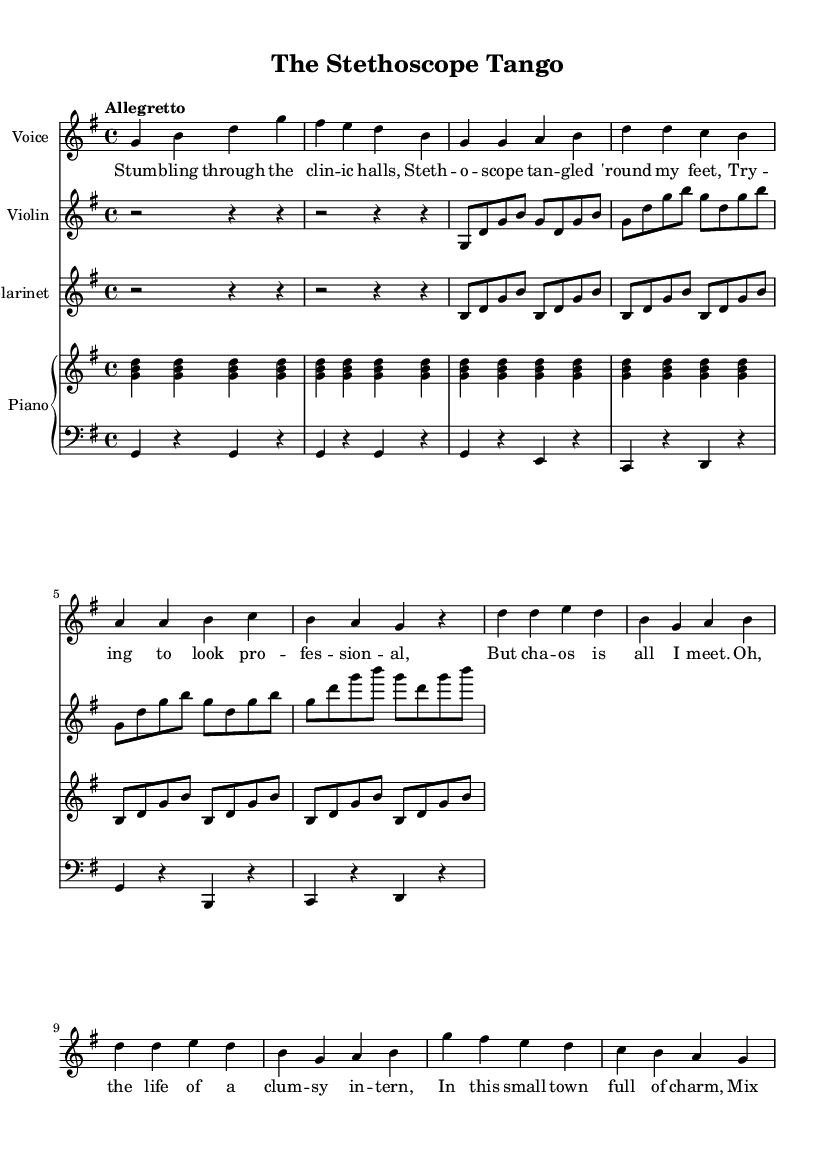What is the key signature of this music? The key signature is G major, which has one sharp (F#). We can find this by looking at the beginning of the staff where the sharps or flats are indicated.
Answer: G major What is the time signature of this music? The time signature is 4/4. This is identified by the fraction symbol displayed at the beginning of the score indicating four beats per measure, with the quarter note being one beat.
Answer: 4/4 What is the tempo indication for this piece? The tempo indication is "Allegretto." This term is typically indicated in the tempo marking at the beginning of the score and suggests a moderately fast pace.
Answer: Allegretto What is the instrumentation used in this opera? The instrumentation includes Voice, Violin, Clarinet, and Piano. The names of the instruments are listed at the start of each staff in the score.
Answer: Voice, Violin, Clarinet, Piano How many measures are there in the introduction? There are 2 measures in the introduction. By counting the groups of four beats in the introduction section, we determine the total.
Answer: 2 measures In the chorus, what device is used to create a sense of humor in the lyrics? The device used is "comic relief." The playful mishaps described in the lyrics contribute to the humorous tone typical in comic opera. This can be inferred from the light-hearted context and the intern's clumsiness mentioned in the lyrics.
Answer: Comic relief What is the primary theme of this comic opera? The primary theme is "the life of a clumsy intern." This is determined by examining the lyrics, which tell a humorous story about the intern's chaotic experiences while trying to maintain professionalism.
Answer: The life of a clumsy intern 